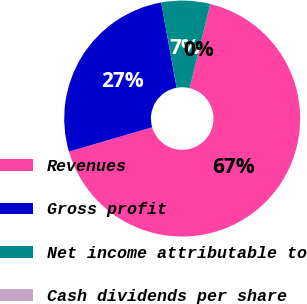<chart> <loc_0><loc_0><loc_500><loc_500><pie_chart><fcel>Revenues<fcel>Gross profit<fcel>Net income attributable to<fcel>Cash dividends per share<nl><fcel>66.66%<fcel>26.67%<fcel>6.67%<fcel>0.0%<nl></chart> 